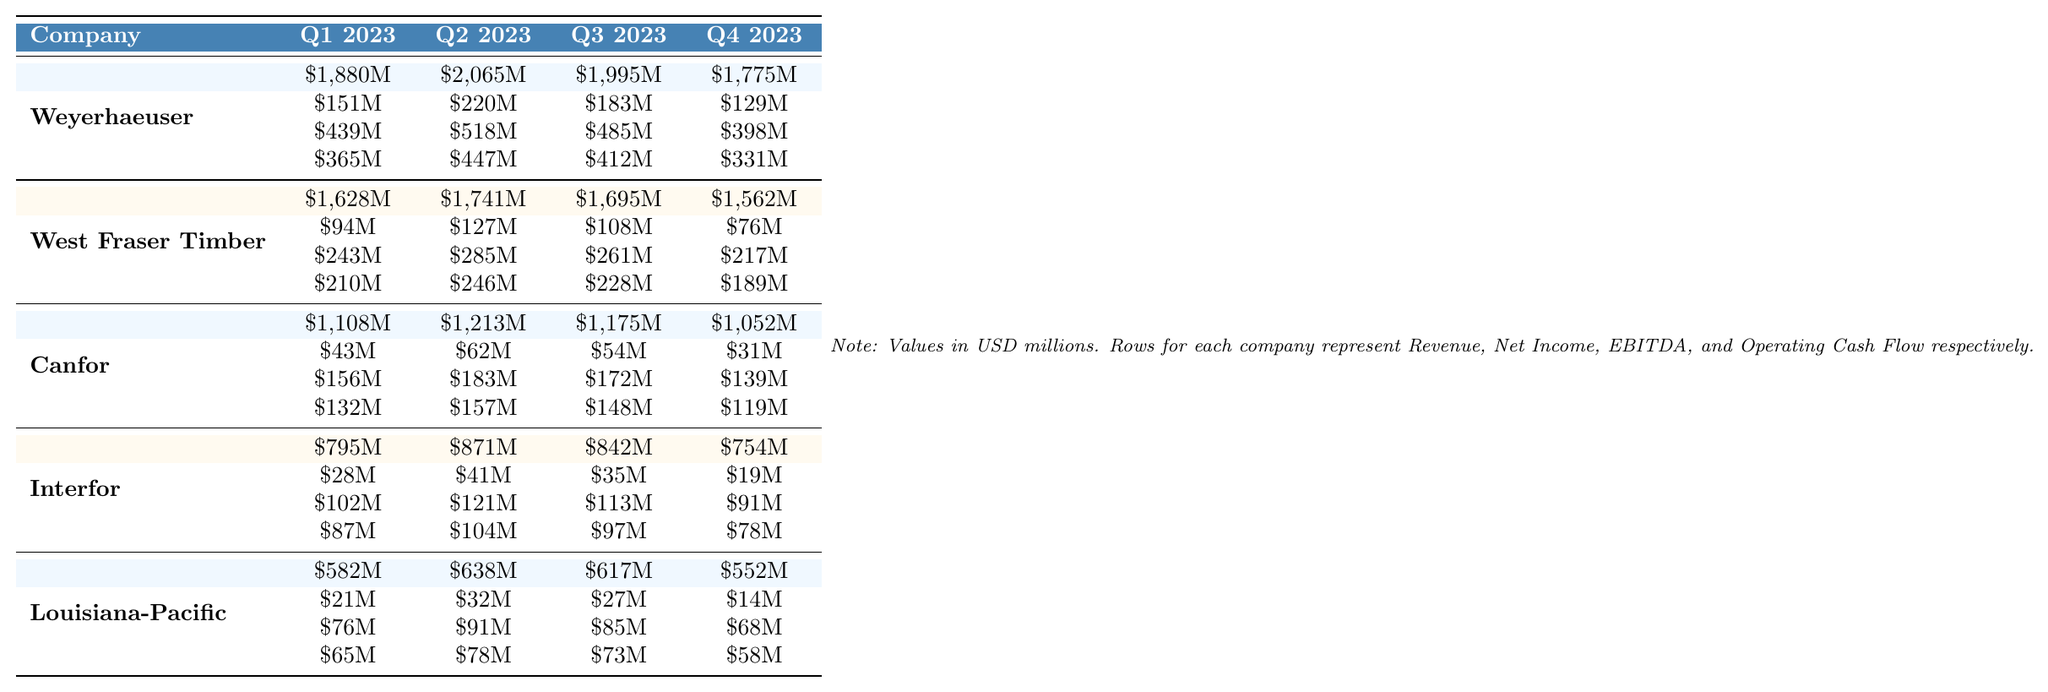What was Weyerhaeuser's highest quarterly revenue in 2023? Weyerhaeuser's revenues for each quarter are \$1,880M (Q1), \$2,065M (Q2), \$1,995M (Q3), and \$1,775M (Q4). By comparing these values, the highest revenue is \$2,065M in Q2.
Answer: \$2,065M Which company had the highest net income in Q2 2023? The net incomes for Q2 2023 are as follows: Weyerhaeuser - \$220M, West Fraser Timber - \$127M, Canfor - \$62M, Interfor - \$41M, and Louisiana-Pacific - \$32M. The highest net income is \$220M from Weyerhaeuser.
Answer: Weyerhaeuser What is the total EBITDA for Canfor over all quarters? Canfor's EBITDA values are: \$156M (Q1), \$183M (Q2), \$172M (Q3), and \$139M (Q4). Summing these gives \$156M + \$183M + \$172M + \$139M = \$650M.
Answer: \$650M Did Louisiana-Pacific experience an increase in operating cash flow from Q1 to Q2 2023? Louisiana-Pacific's operating cash flow for Q1 is \$65M and for Q2 is \$78M. Since \$78M is greater than \$65M, it indicates an increase.
Answer: Yes What was the average net income for West Fraser Timber over 2023? West Fraser Timber's net income values are \$94M (Q1), \$127M (Q2), \$108M (Q3), and \$76M (Q4). The sum is \$94M + \$127M + \$108M + \$76M = \$405M. Dividing this by 4 gives an average of \$405M / 4 = \$101.25M.
Answer: \$101.25M Which company had the lowest operating cash flow in Q4 2023? The operating cash flow for each company in Q4 2023 is as follows: Weyerhaeuser - \$331M, West Fraser Timber - \$189M, Canfor - \$119M, Interfor - \$78M, and Louisiana-Pacific - \$58M. The lowest value is \$58M from Louisiana-Pacific.
Answer: Louisiana-Pacific What was the change in revenue for Interfor from Q1 to Q4 2023? Interfor's revenue for Q1 is \$795M and for Q4 is \$754M. To find the change, subtract \$754M from \$795M, which gives \$795M - \$754M = \$41M (a decrease).
Answer: \$41M decrease What percentage of total EBITDA does Weyerhaeuser account for in Q2 2023? Weyerhaeuser's EBITDA in Q2 2023 is \$518M. The total EBITDA for all companies in Q2 2023 is \$518M (Weyerhaeuser) + \$285M (West Fraser) + \$183M (Canfor) + \$121M (Interfor) + \$91M (Louisiana-Pacific) = \$1,198M. The percentage is (\$518M / \$1,198M) * 100 = 43.3%.
Answer: 43.3% Which company showed a decline in both revenue and net income from Q1 to Q4 2023? Observing the data, Weyerhaeuser's revenue decreased from \$1,880M to \$1,775M and net income decreased from \$151M to \$129M. Similarly, Canfor showed a decline in revenue from \$1,108M to \$1,052M and net income from \$43M to \$31M. Interfor's revenue went from \$795M to \$754M and net income from \$28M to \$19M, indicating declines too. However, Weyerhaeuser, Canfor, and Interfor all show declining values.
Answer: Weyerhaeuser, Canfor, Interfor What was the total revenue of all companies combined in Q3 2023? The revenues for Q3 2023 are: Weyerhaeuser - \$1,995M, West Fraser Timber - \$1,695M, Canfor - \$1,175M, Interfor - \$842M, and Louisiana-Pacific - \$617M. Adding these together, we get \$1,995M + \$1,695M + \$1,175M + \$842M + \$617M = \$7,524M.
Answer: \$7,524M 